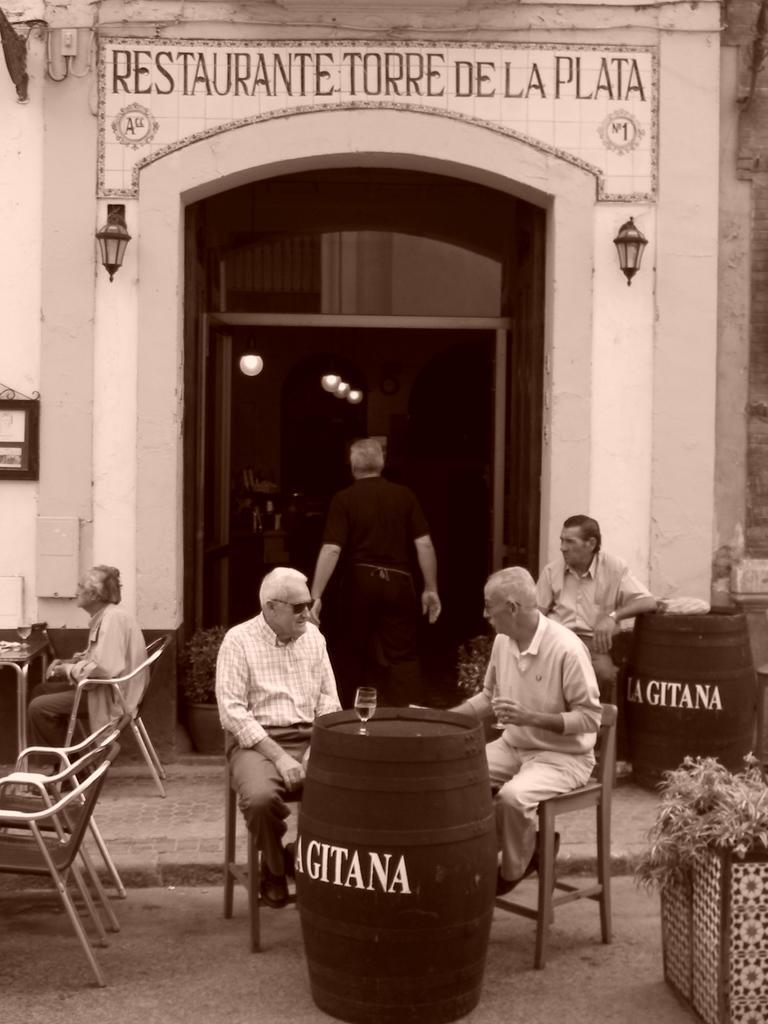In one or two sentences, can you explain what this image depicts? Here we can see persons sitting on chairs in front of a table. We can see a glass here and empty chairs. This is a restaurant. We can see lights inside the restaurant and one man is standing here. At the right side of the picture we can see a plant with pot. 